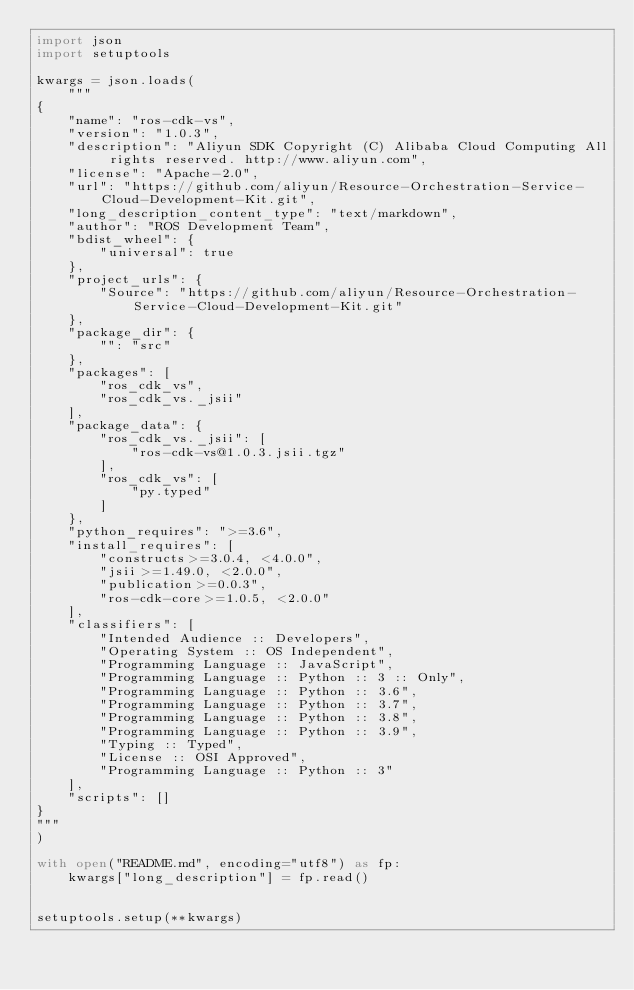<code> <loc_0><loc_0><loc_500><loc_500><_Python_>import json
import setuptools

kwargs = json.loads(
    """
{
    "name": "ros-cdk-vs",
    "version": "1.0.3",
    "description": "Aliyun SDK Copyright (C) Alibaba Cloud Computing All rights reserved. http://www.aliyun.com",
    "license": "Apache-2.0",
    "url": "https://github.com/aliyun/Resource-Orchestration-Service-Cloud-Development-Kit.git",
    "long_description_content_type": "text/markdown",
    "author": "ROS Development Team",
    "bdist_wheel": {
        "universal": true
    },
    "project_urls": {
        "Source": "https://github.com/aliyun/Resource-Orchestration-Service-Cloud-Development-Kit.git"
    },
    "package_dir": {
        "": "src"
    },
    "packages": [
        "ros_cdk_vs",
        "ros_cdk_vs._jsii"
    ],
    "package_data": {
        "ros_cdk_vs._jsii": [
            "ros-cdk-vs@1.0.3.jsii.tgz"
        ],
        "ros_cdk_vs": [
            "py.typed"
        ]
    },
    "python_requires": ">=3.6",
    "install_requires": [
        "constructs>=3.0.4, <4.0.0",
        "jsii>=1.49.0, <2.0.0",
        "publication>=0.0.3",
        "ros-cdk-core>=1.0.5, <2.0.0"
    ],
    "classifiers": [
        "Intended Audience :: Developers",
        "Operating System :: OS Independent",
        "Programming Language :: JavaScript",
        "Programming Language :: Python :: 3 :: Only",
        "Programming Language :: Python :: 3.6",
        "Programming Language :: Python :: 3.7",
        "Programming Language :: Python :: 3.8",
        "Programming Language :: Python :: 3.9",
        "Typing :: Typed",
        "License :: OSI Approved",
        "Programming Language :: Python :: 3"
    ],
    "scripts": []
}
"""
)

with open("README.md", encoding="utf8") as fp:
    kwargs["long_description"] = fp.read()


setuptools.setup(**kwargs)
</code> 